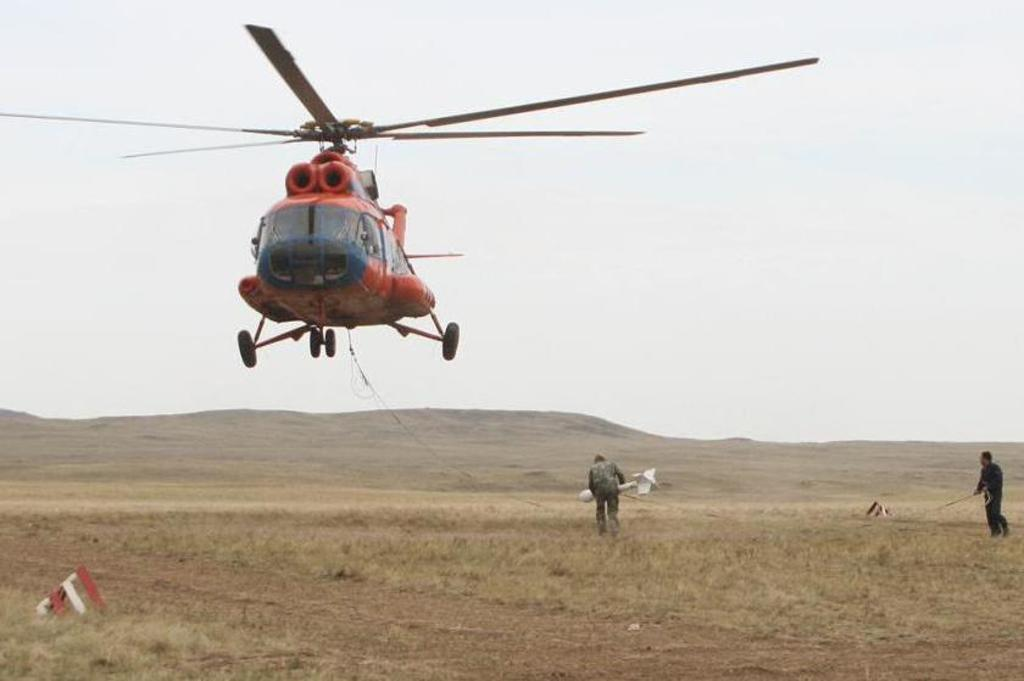What are the persons in the image wearing? The persons in the image are wearing clothes. What can be seen above the ground in the image? There is a helicopter above the ground in the image. What is visible in the background of the image? There is a sky visible in the background of the image. What type of cream can be seen on the spoon in the image? There is no spoon or cream present in the image. 